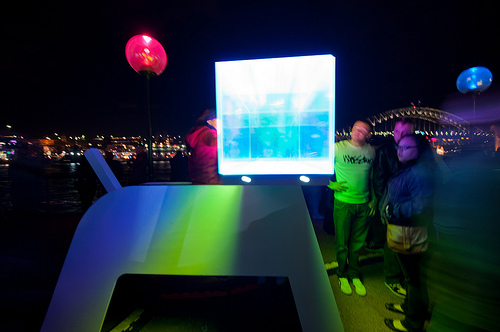<image>
Is there a screen in front of the man? Yes. The screen is positioned in front of the man, appearing closer to the camera viewpoint. 